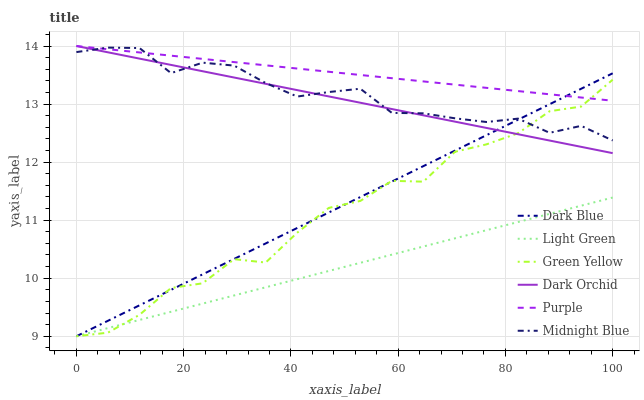Does Light Green have the minimum area under the curve?
Answer yes or no. Yes. Does Purple have the maximum area under the curve?
Answer yes or no. Yes. Does Dark Orchid have the minimum area under the curve?
Answer yes or no. No. Does Dark Orchid have the maximum area under the curve?
Answer yes or no. No. Is Dark Blue the smoothest?
Answer yes or no. Yes. Is Green Yellow the roughest?
Answer yes or no. Yes. Is Purple the smoothest?
Answer yes or no. No. Is Purple the roughest?
Answer yes or no. No. Does Dark Blue have the lowest value?
Answer yes or no. Yes. Does Dark Orchid have the lowest value?
Answer yes or no. No. Does Dark Orchid have the highest value?
Answer yes or no. Yes. Does Dark Blue have the highest value?
Answer yes or no. No. Is Light Green less than Purple?
Answer yes or no. Yes. Is Dark Orchid greater than Light Green?
Answer yes or no. Yes. Does Dark Orchid intersect Green Yellow?
Answer yes or no. Yes. Is Dark Orchid less than Green Yellow?
Answer yes or no. No. Is Dark Orchid greater than Green Yellow?
Answer yes or no. No. Does Light Green intersect Purple?
Answer yes or no. No. 